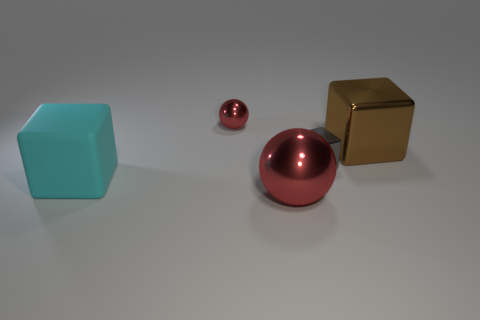Is there anything else that is the same size as the cyan matte block?
Your response must be concise. Yes. Are any small red matte spheres visible?
Offer a terse response. No. Does the tiny sphere have the same color as the big shiny thing in front of the large cyan rubber block?
Keep it short and to the point. Yes. There is a thing that is the same color as the big metallic sphere; what is its material?
Give a very brief answer. Metal. What shape is the tiny object in front of the small thing on the left side of the red object in front of the matte cube?
Your answer should be compact. Cube. There is a rubber thing; what shape is it?
Provide a short and direct response. Cube. There is a thing that is in front of the cyan block; what is its color?
Make the answer very short. Red. There is a cyan block that is in front of the brown metallic object; is it the same size as the brown metal thing?
Offer a very short reply. Yes. There is another matte object that is the same shape as the small gray thing; what is its size?
Give a very brief answer. Large. Is the large cyan thing the same shape as the brown object?
Provide a short and direct response. Yes. 